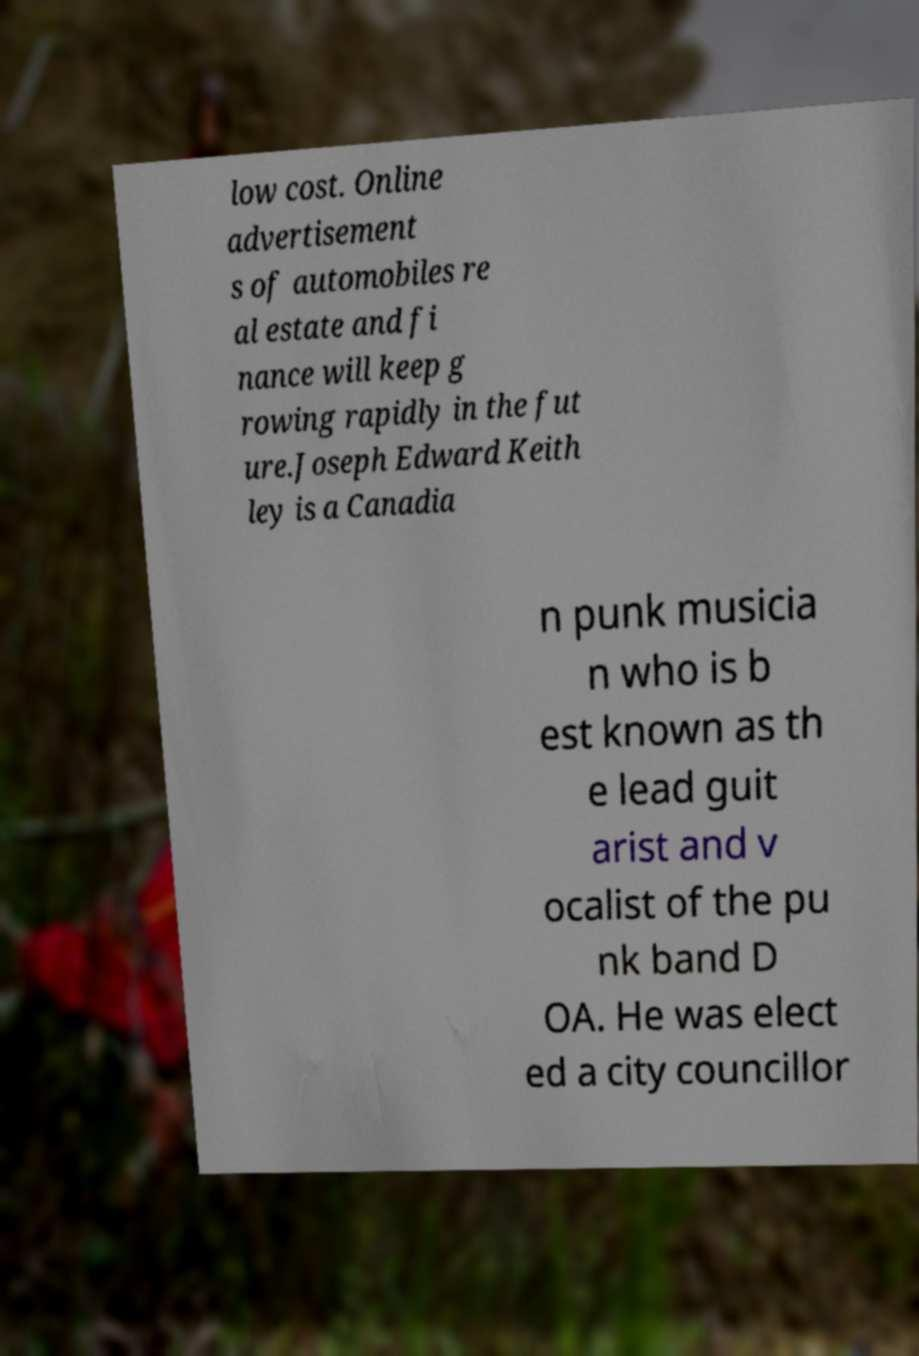Could you extract and type out the text from this image? low cost. Online advertisement s of automobiles re al estate and fi nance will keep g rowing rapidly in the fut ure.Joseph Edward Keith ley is a Canadia n punk musicia n who is b est known as th e lead guit arist and v ocalist of the pu nk band D OA. He was elect ed a city councillor 